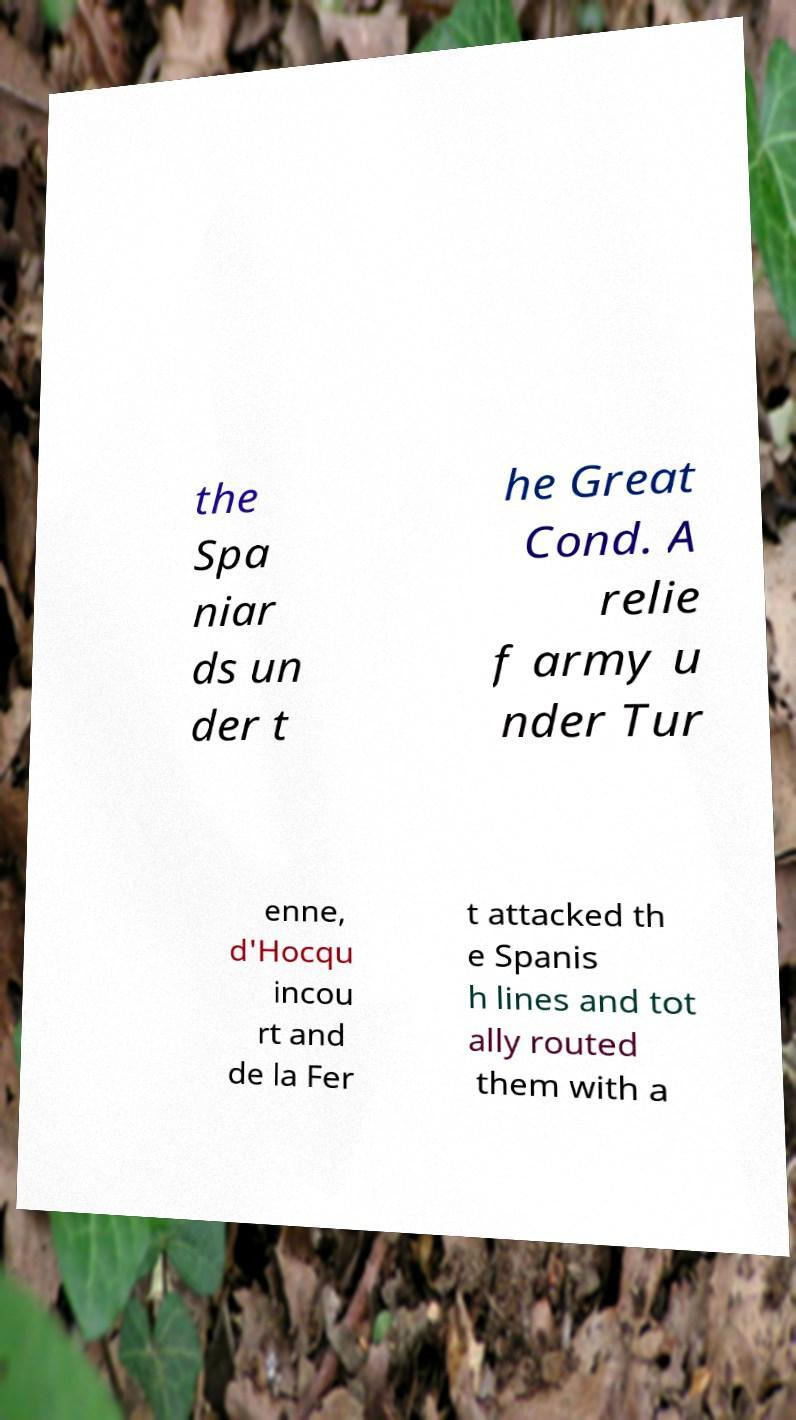I need the written content from this picture converted into text. Can you do that? the Spa niar ds un der t he Great Cond. A relie f army u nder Tur enne, d'Hocqu incou rt and de la Fer t attacked th e Spanis h lines and tot ally routed them with a 